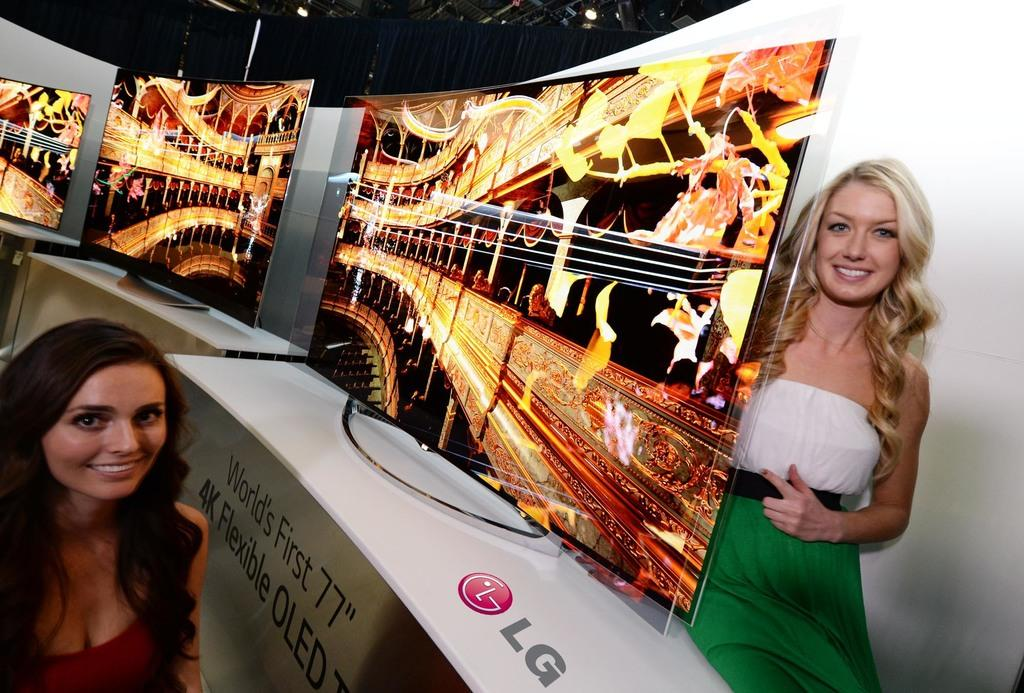What electronic devices can be seen in the image? There are television screens in the image. What structural elements are present in the image? There are beams in the image. What type of illumination is visible in the image? There are lights in the image. What type of furniture is present in the image? There are tables in the image. What is written or displayed on a table in the image? There is text on a table in the image. What type of symbol is present on a table in the image? There is a logo on a table in the image. Who is present in the image? There are women in the image. What is the facial expression of the women in the image? The women are smiling in the image. How much profit does the earth make in the image? There is no mention of profit or the earth in the image; it features television screens, beams, lights, tables, text, a logo, and women. What type of bird is present in the image? There is no bird, including a turkey, present in the image. 